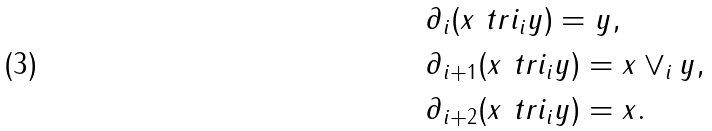Convert formula to latex. <formula><loc_0><loc_0><loc_500><loc_500>& \partial _ { i } ( x \ t r i _ { i } y ) = y , \\ & \partial _ { i + 1 } ( x \ t r i _ { i } y ) = x \vee _ { i } y , \\ & \partial _ { i + 2 } ( x \ t r i _ { i } y ) = x .</formula> 